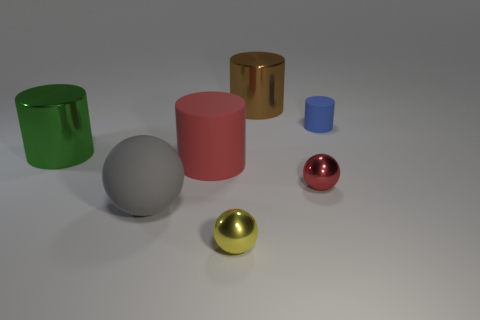Add 1 blue rubber cylinders. How many objects exist? 8 Subtract all big gray spheres. How many spheres are left? 2 Subtract 1 cylinders. How many cylinders are left? 3 Subtract all blue cylinders. How many cylinders are left? 3 Subtract 0 gray cubes. How many objects are left? 7 Subtract all cylinders. How many objects are left? 3 Subtract all gray spheres. Subtract all green cylinders. How many spheres are left? 2 Subtract all purple blocks. How many purple balls are left? 0 Subtract all tiny spheres. Subtract all red balls. How many objects are left? 4 Add 5 balls. How many balls are left? 8 